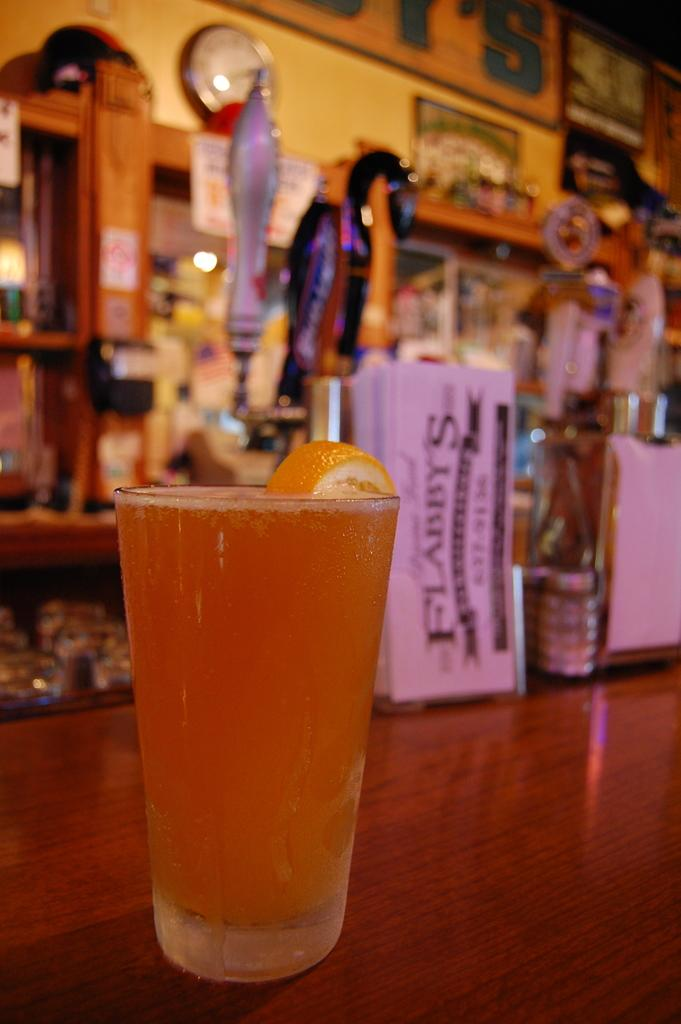<image>
Relay a brief, clear account of the picture shown. A galss of beer with an orange on it on the counter at Flabbys. 